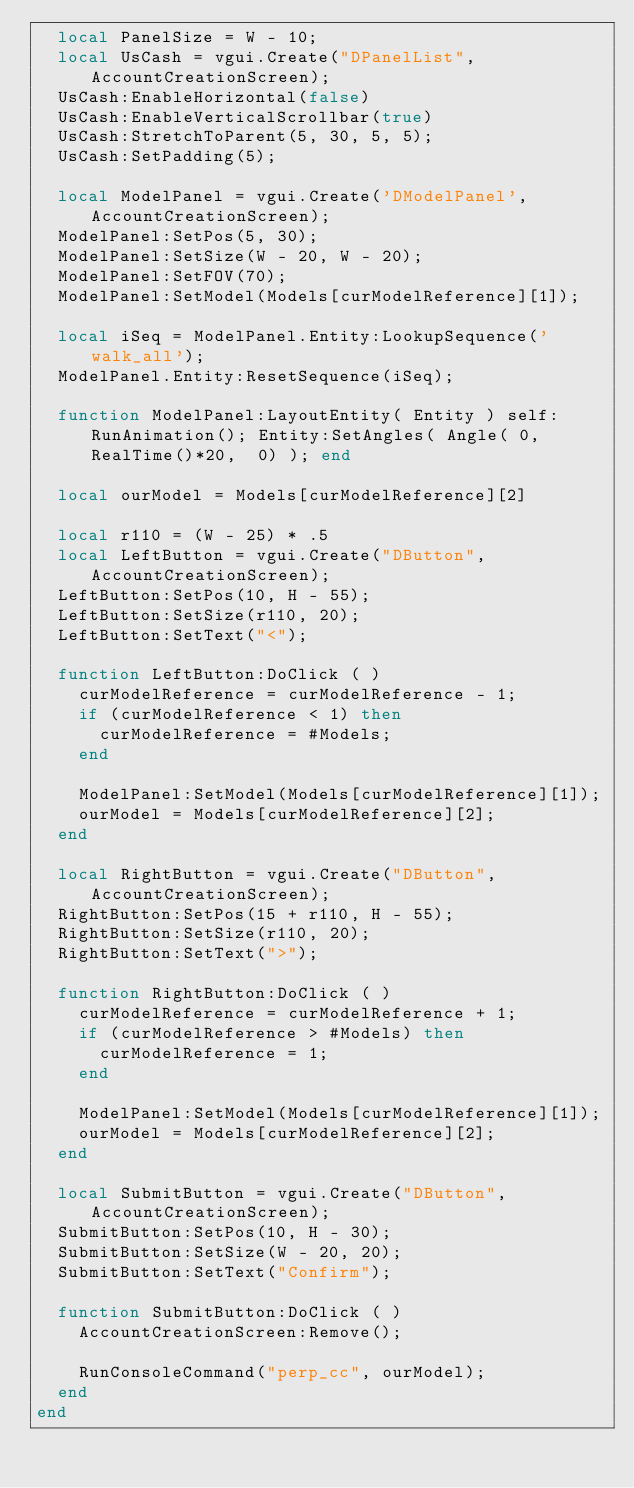<code> <loc_0><loc_0><loc_500><loc_500><_Lua_>	local PanelSize = W - 10;
	local UsCash = vgui.Create("DPanelList", AccountCreationScreen);
	UsCash:EnableHorizontal(false)
	UsCash:EnableVerticalScrollbar(true)
	UsCash:StretchToParent(5, 30, 5, 5);
	UsCash:SetPadding(5);
	
	local ModelPanel = vgui.Create('DModelPanel', AccountCreationScreen);
	ModelPanel:SetPos(5, 30);
	ModelPanel:SetSize(W - 20, W - 20);
	ModelPanel:SetFOV(70);
	ModelPanel:SetModel(Models[curModelReference][1]);
	
	local iSeq = ModelPanel.Entity:LookupSequence('walk_all');
	ModelPanel.Entity:ResetSequence(iSeq);
	
	function ModelPanel:LayoutEntity( Entity ) self:RunAnimation(); Entity:SetAngles( Angle( 0, RealTime()*20,  0) ); end

	local ourModel = Models[curModelReference][2]
	
	local r110 = (W - 25) * .5
	local LeftButton = vgui.Create("DButton", AccountCreationScreen);
	LeftButton:SetPos(10, H - 55);
	LeftButton:SetSize(r110, 20);
	LeftButton:SetText("<");
	
	function LeftButton:DoClick ( )
		curModelReference = curModelReference - 1;
		if (curModelReference < 1) then
			curModelReference = #Models;
		end
		
		ModelPanel:SetModel(Models[curModelReference][1]);
		ourModel = Models[curModelReference][2];
	end
		
	local RightButton = vgui.Create("DButton", AccountCreationScreen);
	RightButton:SetPos(15 + r110, H - 55);
	RightButton:SetSize(r110, 20);
	RightButton:SetText(">");
		
	function RightButton:DoClick ( )
		curModelReference = curModelReference + 1;
		if (curModelReference > #Models) then
			curModelReference = 1;
		end
			
		ModelPanel:SetModel(Models[curModelReference][1]);
		ourModel = Models[curModelReference][2];
	end
	
	local SubmitButton = vgui.Create("DButton", AccountCreationScreen);
	SubmitButton:SetPos(10, H - 30);
	SubmitButton:SetSize(W - 20, 20);
	SubmitButton:SetText("Confirm");
		
	function SubmitButton:DoClick ( )
		AccountCreationScreen:Remove();
			
		RunConsoleCommand("perp_cc", ourModel);
	end
end
</code> 